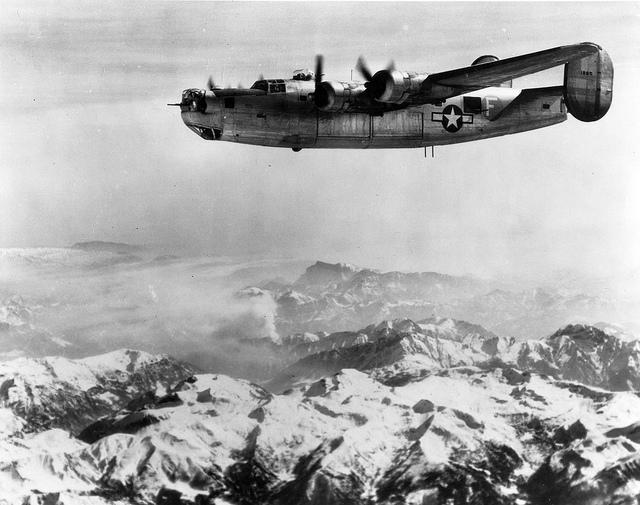What continent is this plane flying over?
Short answer required. Antarctica. What is below the plane?
Concise answer only. Mountains. Is this a plane made after the year 2000?
Keep it brief. No. 